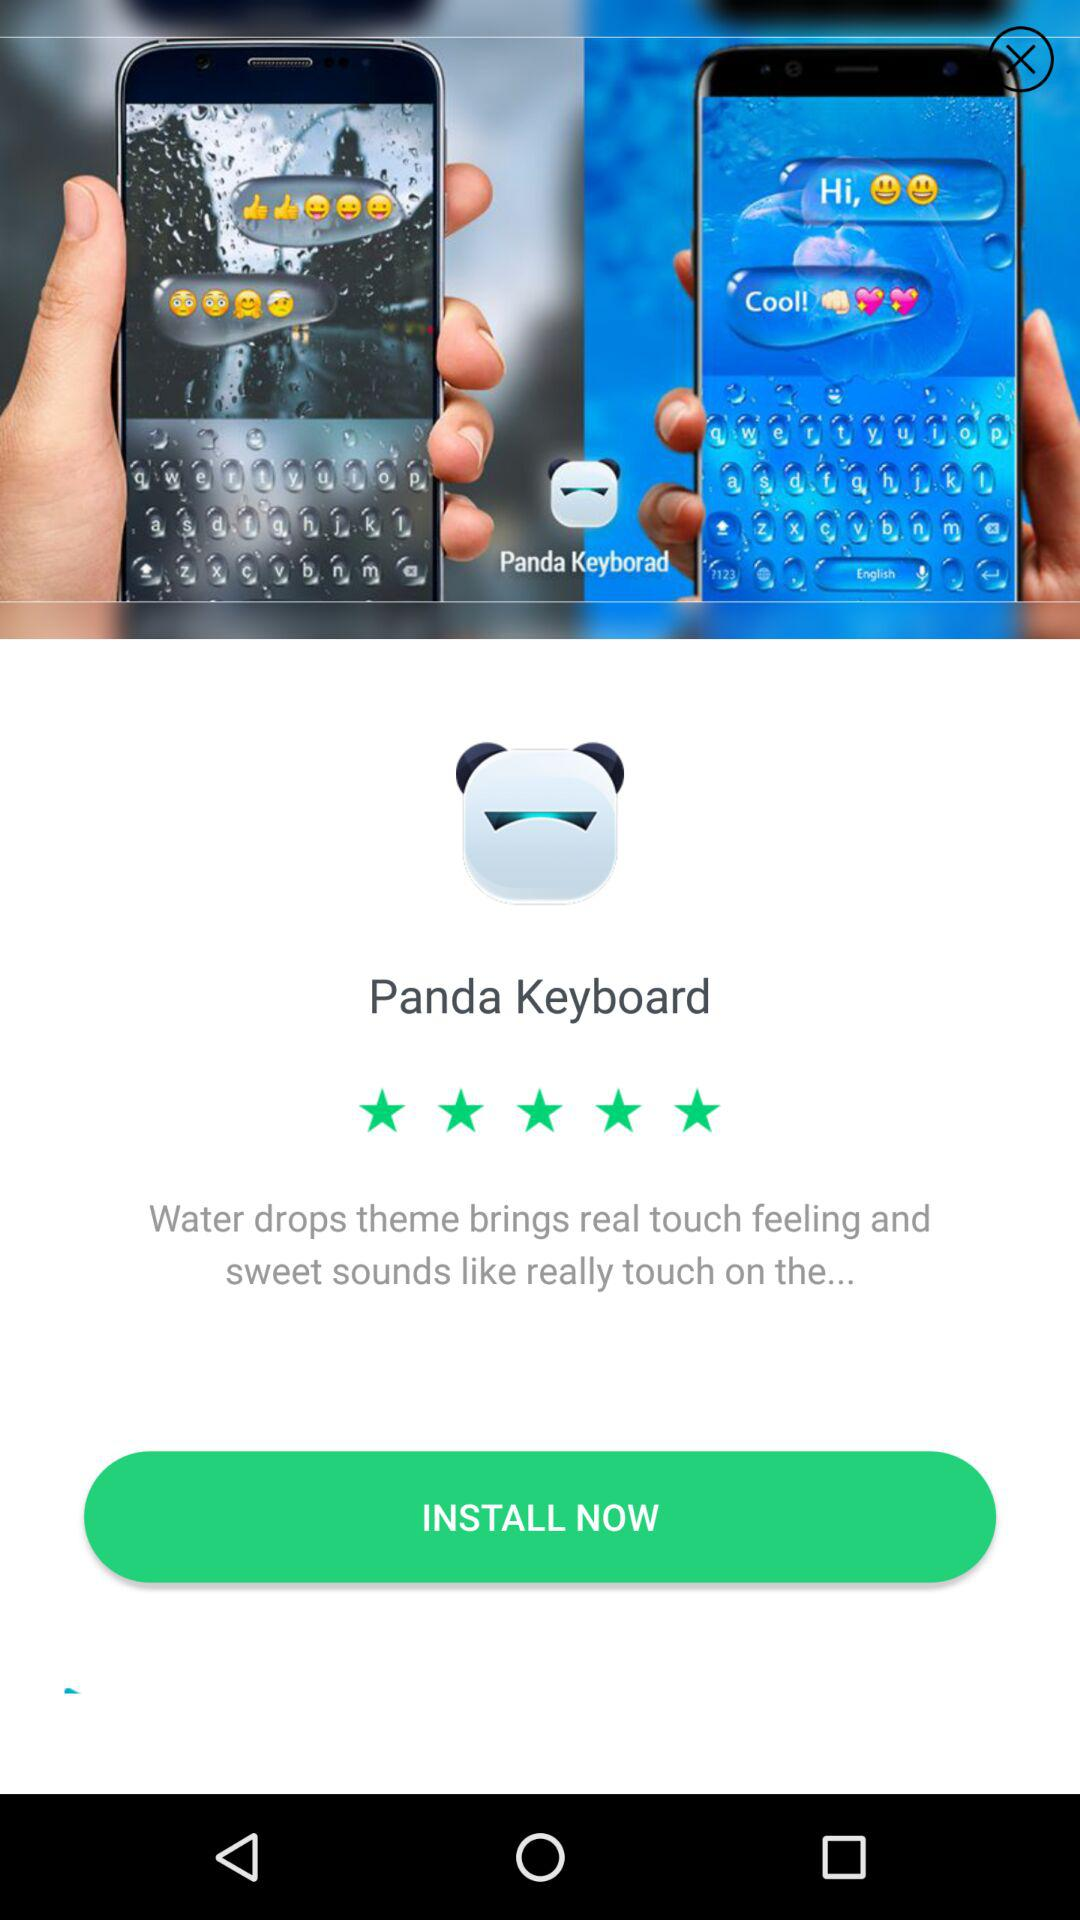What is the application name? The name of the application is "Panda Keyboard". 